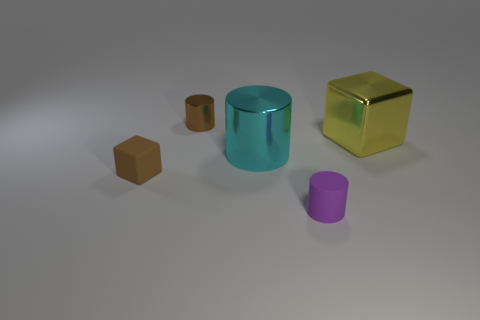The small block is what color? brown 